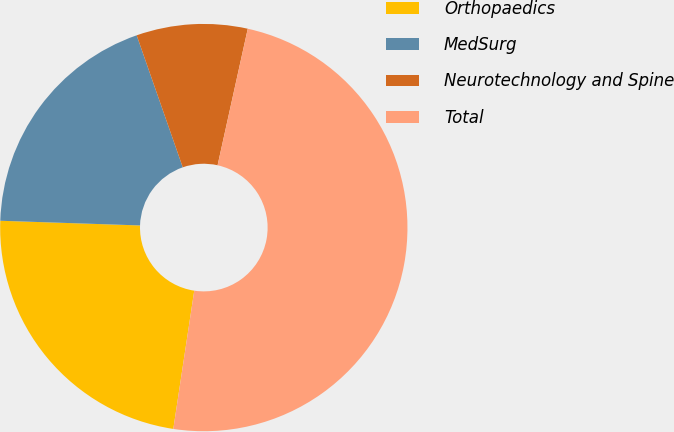Convert chart. <chart><loc_0><loc_0><loc_500><loc_500><pie_chart><fcel>Orthopaedics<fcel>MedSurg<fcel>Neurotechnology and Spine<fcel>Total<nl><fcel>23.14%<fcel>19.12%<fcel>8.81%<fcel>48.93%<nl></chart> 